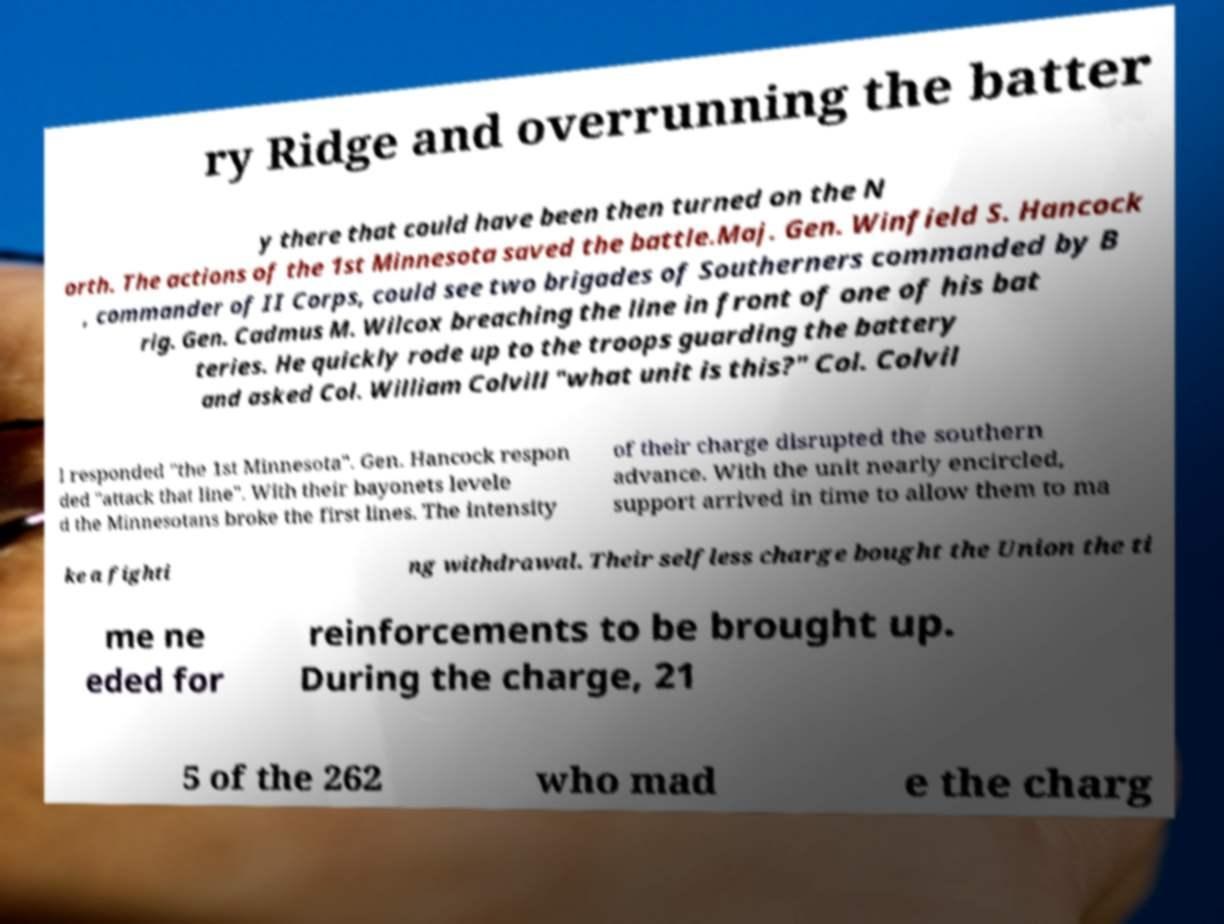Please read and relay the text visible in this image. What does it say? ry Ridge and overrunning the batter y there that could have been then turned on the N orth. The actions of the 1st Minnesota saved the battle.Maj. Gen. Winfield S. Hancock , commander of II Corps, could see two brigades of Southerners commanded by B rig. Gen. Cadmus M. Wilcox breaching the line in front of one of his bat teries. He quickly rode up to the troops guarding the battery and asked Col. William Colvill "what unit is this?" Col. Colvil l responded "the 1st Minnesota". Gen. Hancock respon ded "attack that line". With their bayonets levele d the Minnesotans broke the first lines. The intensity of their charge disrupted the southern advance. With the unit nearly encircled, support arrived in time to allow them to ma ke a fighti ng withdrawal. Their selfless charge bought the Union the ti me ne eded for reinforcements to be brought up. During the charge, 21 5 of the 262 who mad e the charg 